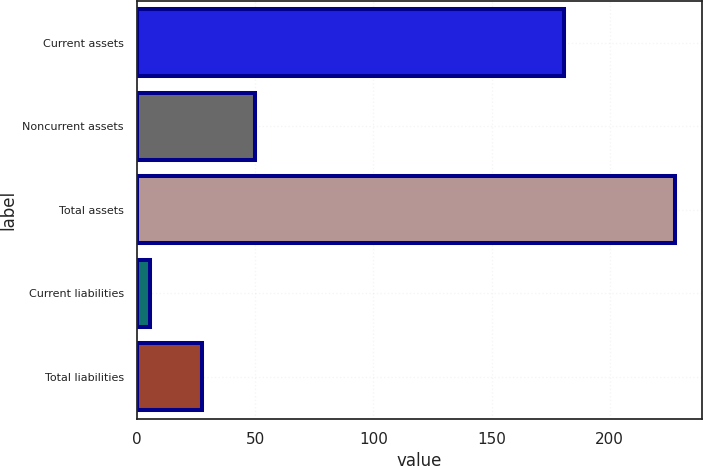Convert chart to OTSL. <chart><loc_0><loc_0><loc_500><loc_500><bar_chart><fcel>Current assets<fcel>Noncurrent assets<fcel>Total assets<fcel>Current liabilities<fcel>Total liabilities<nl><fcel>180.7<fcel>49.84<fcel>227.6<fcel>5.4<fcel>27.62<nl></chart> 